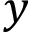Convert formula to latex. <formula><loc_0><loc_0><loc_500><loc_500>y</formula> 